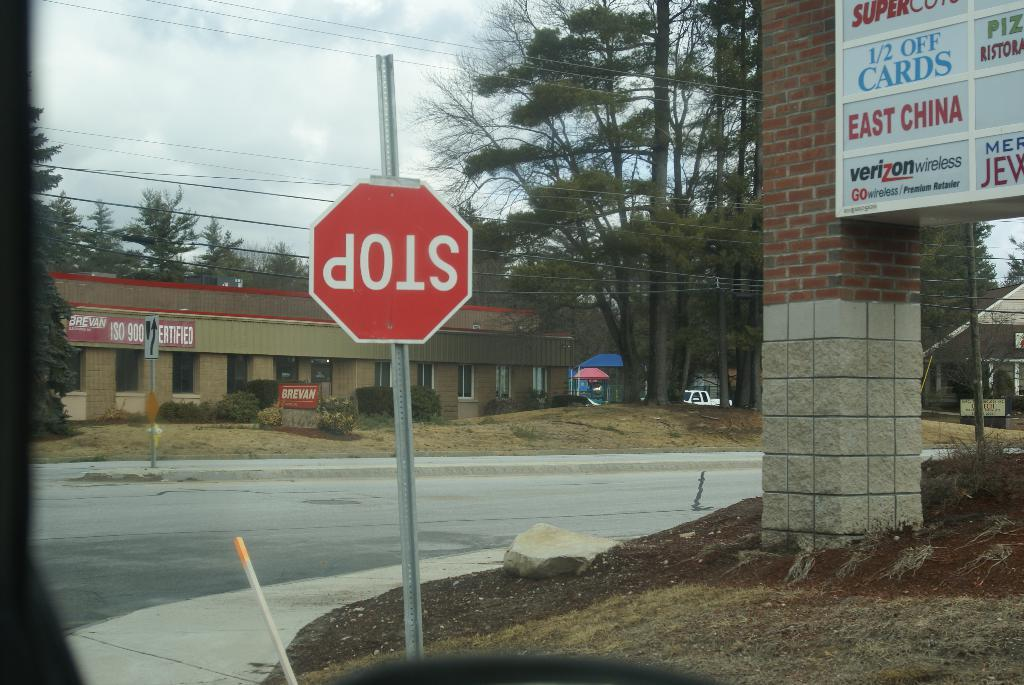<image>
Provide a brief description of the given image. An upside down stop sign near a road and a mall sign. 